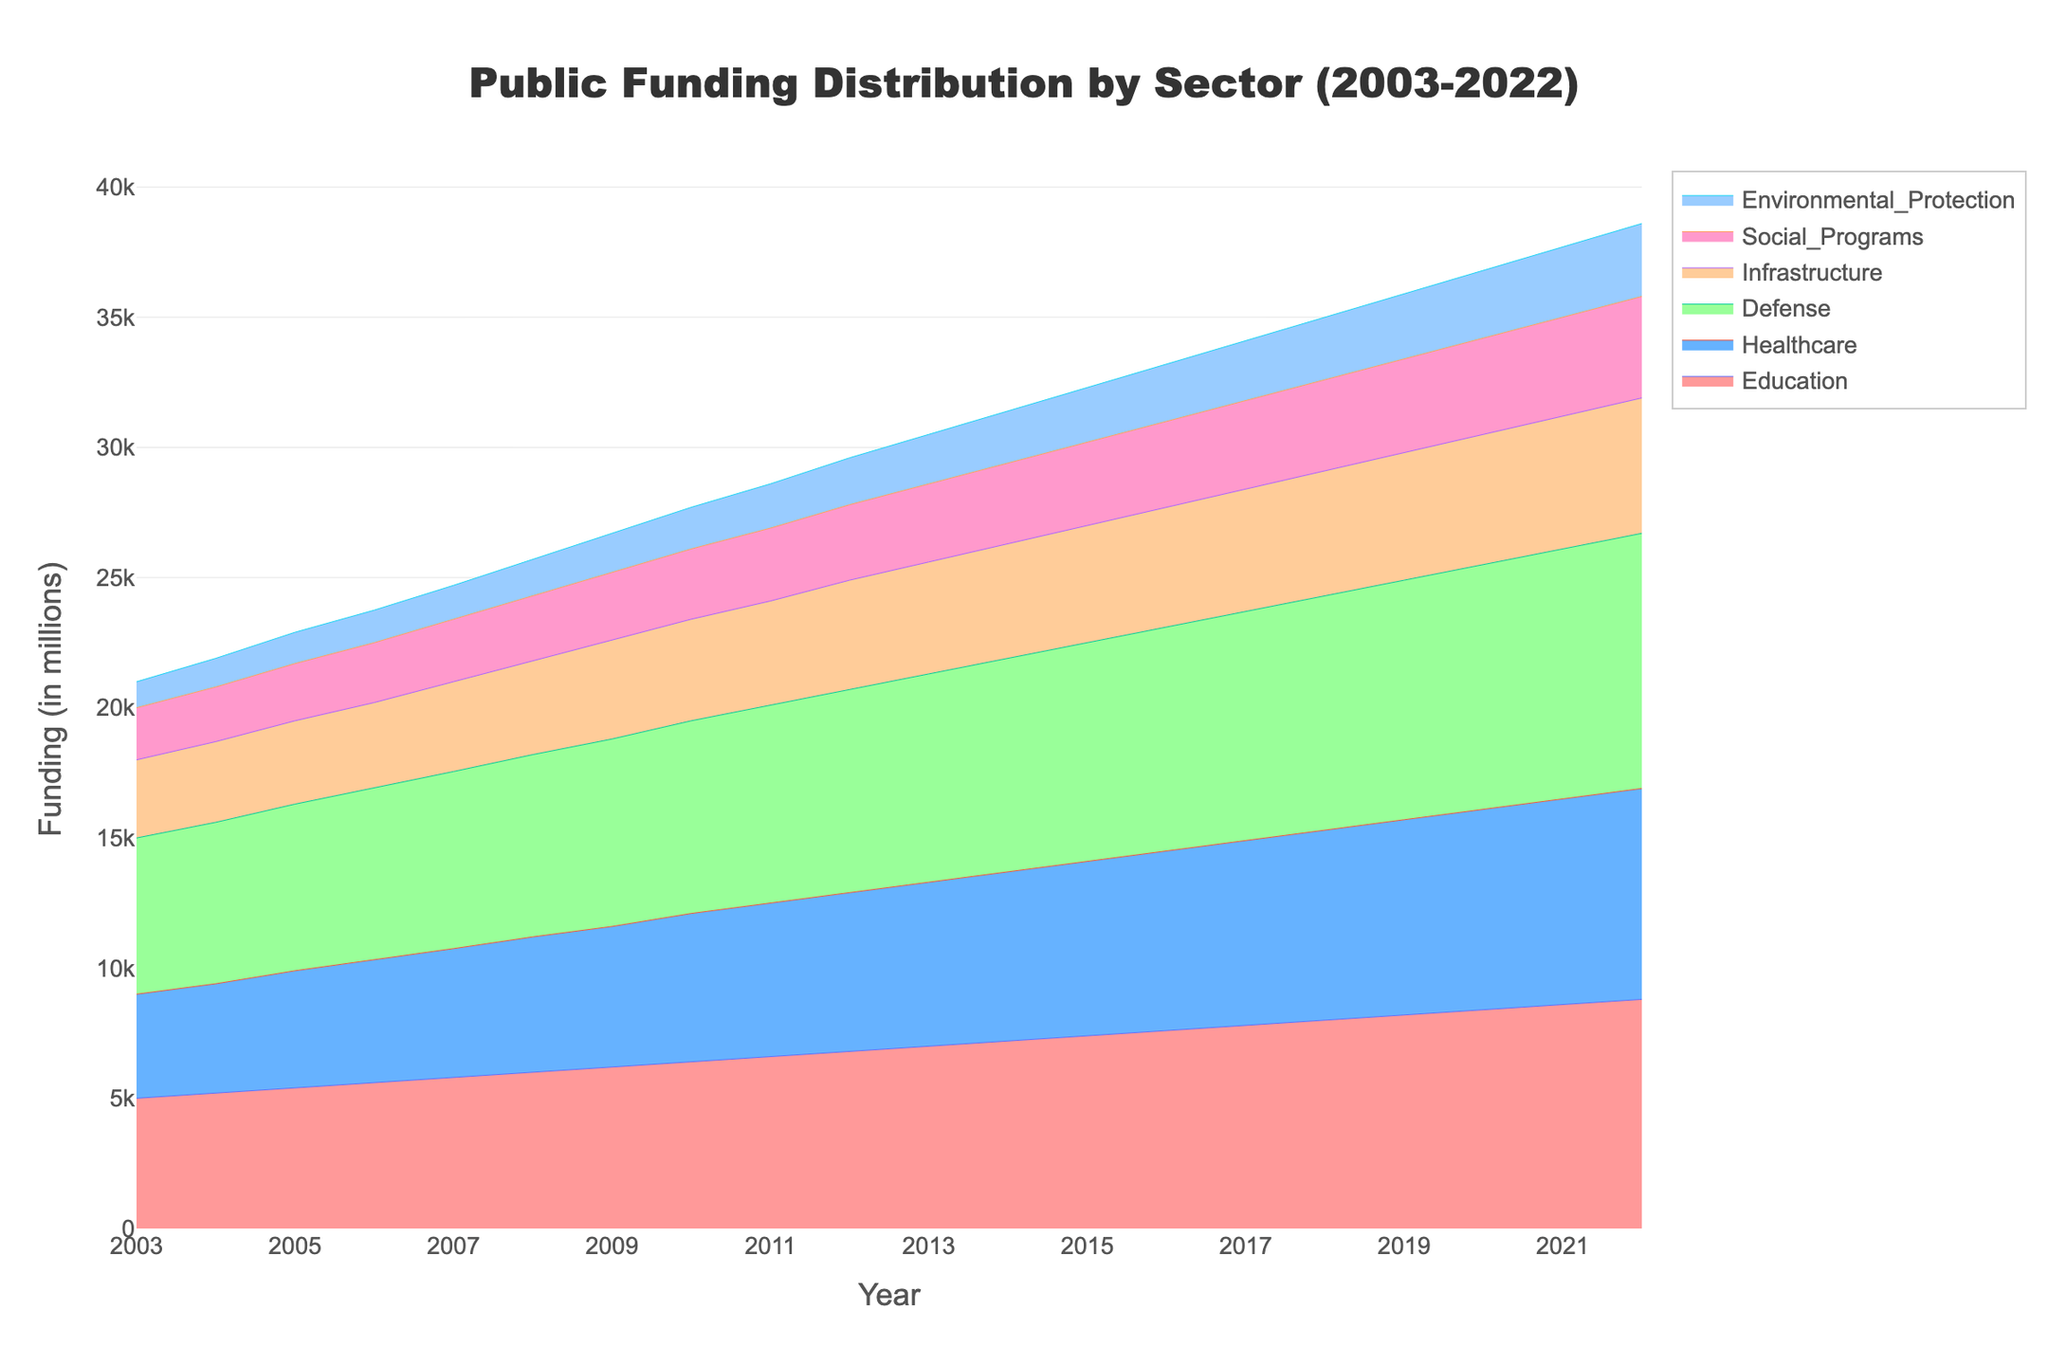What sectors are displayed in the figure? The figure displays various sectors receiving public funding over two decades. Each sector is represented by a different color in the stream graph.
Answer: Education, Healthcare, Defense, Infrastructure, Social Programs, Environmental Protection What is the overall trend in healthcare funding from 2003 to 2022? The healthcare funding seems to increase steadily from 2003 to 2022, as observed by the rising line representing healthcare in the stream graph.
Answer: Increasing Which sector received the highest funding in 2003? By looking at the stream graph, the sector with the highest value in 2003 can be identified by the height of its curve at the start year.
Answer: Defense How does the funding for education compare to infrastructure in 2020? We compare the heights of the respective curves for education and infrastructure in the year 2020 to determine which received more funding.
Answer: Education received more funding What is the total funding for Environmental Protection over the years 2010 to 2015? To find this, we sum the funding values for Environmental Protection from 2010 to 2015 available in the data.
Answer: 9300 Which sector shows the most steady increment in funding over the two decades? A steady increment implies a fairly linear and smooth rise in the curve throughout the years. We need to identify which sector's line follows this pattern closely.
Answer: Education In which year did the funding for Social Programs surpass 3000 million? We trace the line representing Social Programs and check which year first sees it crossing the 3000 million mark.
Answer: 2013 What is the average annual funding for Defense between 2005 and 2010? To find this, we sum the funding values for Defense between 2005 and 2010 and then divide by the number of years, which is 6.
Answer: 6850 How does the trend in Environmental Protection compare to Defense over the years? Examine the curves for Environmental Protection and Defense for their overall trends, whether they increase, decrease, or stay the same, and compare them.
Answer: Both increase, but Defense increases at a significantly higher rate What proportion of the total public funding in 2022 does the Infrastructure sector represent? Calculate the total funding in 2022 by summing the values for all sectors, then find the proportion that Infrastructure represents by dividing its funding by the total.
Answer: 0.15 (or 15%) 